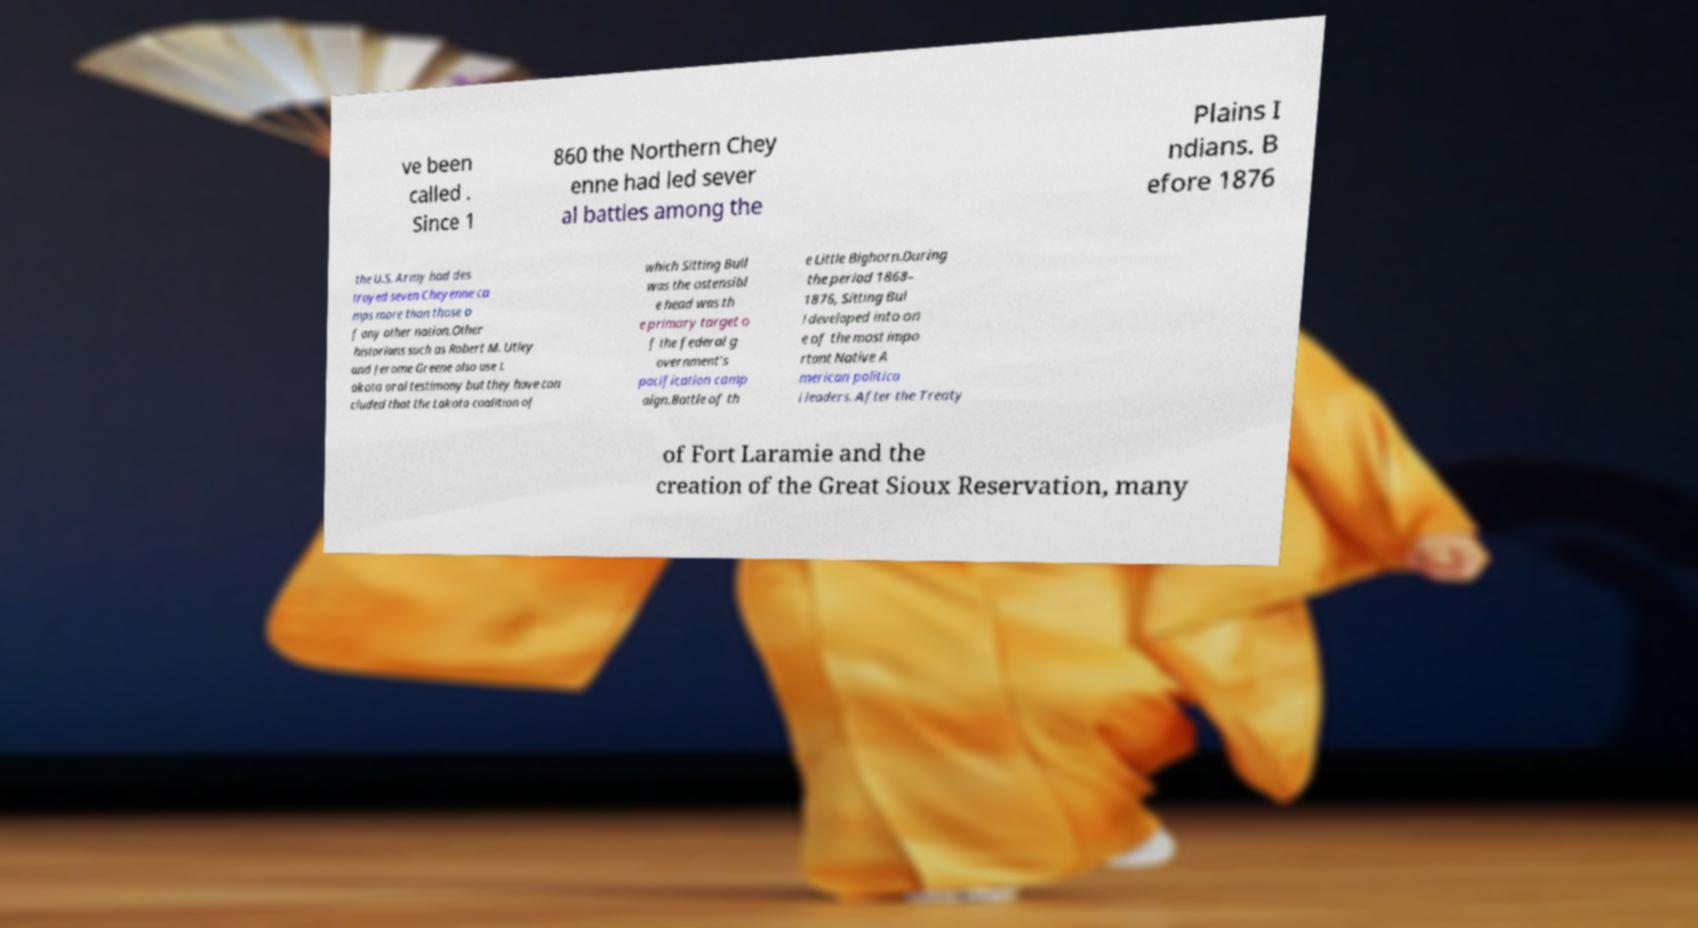What messages or text are displayed in this image? I need them in a readable, typed format. ve been called . Since 1 860 the Northern Chey enne had led sever al battles among the Plains I ndians. B efore 1876 the U.S. Army had des troyed seven Cheyenne ca mps more than those o f any other nation.Other historians such as Robert M. Utley and Jerome Greene also use L akota oral testimony but they have con cluded that the Lakota coalition of which Sitting Bull was the ostensibl e head was th e primary target o f the federal g overnment's pacification camp aign.Battle of th e Little Bighorn.During the period 1868– 1876, Sitting Bul l developed into on e of the most impo rtant Native A merican politica l leaders. After the Treaty of Fort Laramie and the creation of the Great Sioux Reservation, many 